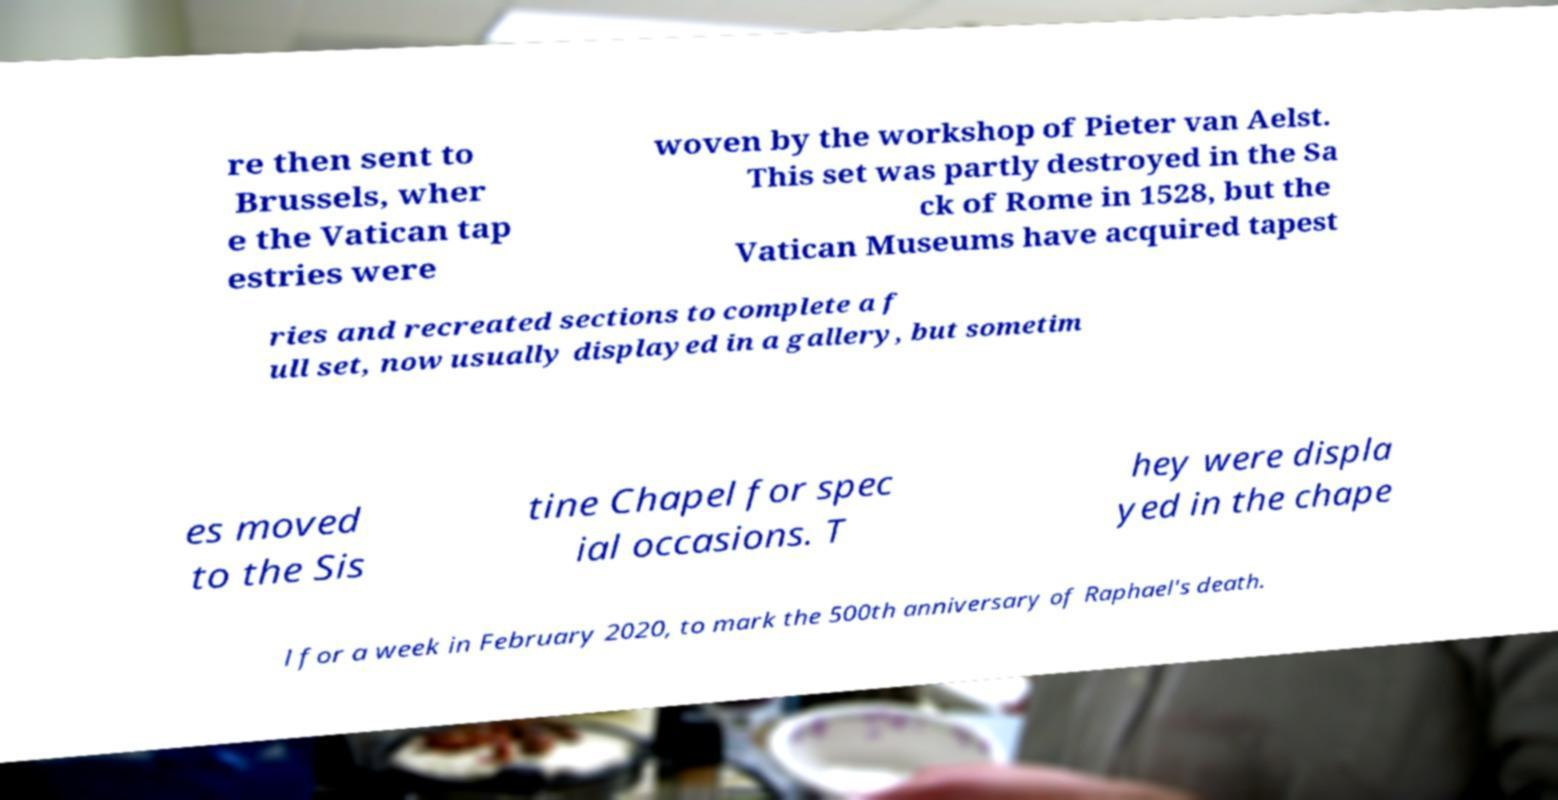Please read and relay the text visible in this image. What does it say? re then sent to Brussels, wher e the Vatican tap estries were woven by the workshop of Pieter van Aelst. This set was partly destroyed in the Sa ck of Rome in 1528, but the Vatican Museums have acquired tapest ries and recreated sections to complete a f ull set, now usually displayed in a gallery, but sometim es moved to the Sis tine Chapel for spec ial occasions. T hey were displa yed in the chape l for a week in February 2020, to mark the 500th anniversary of Raphael's death. 